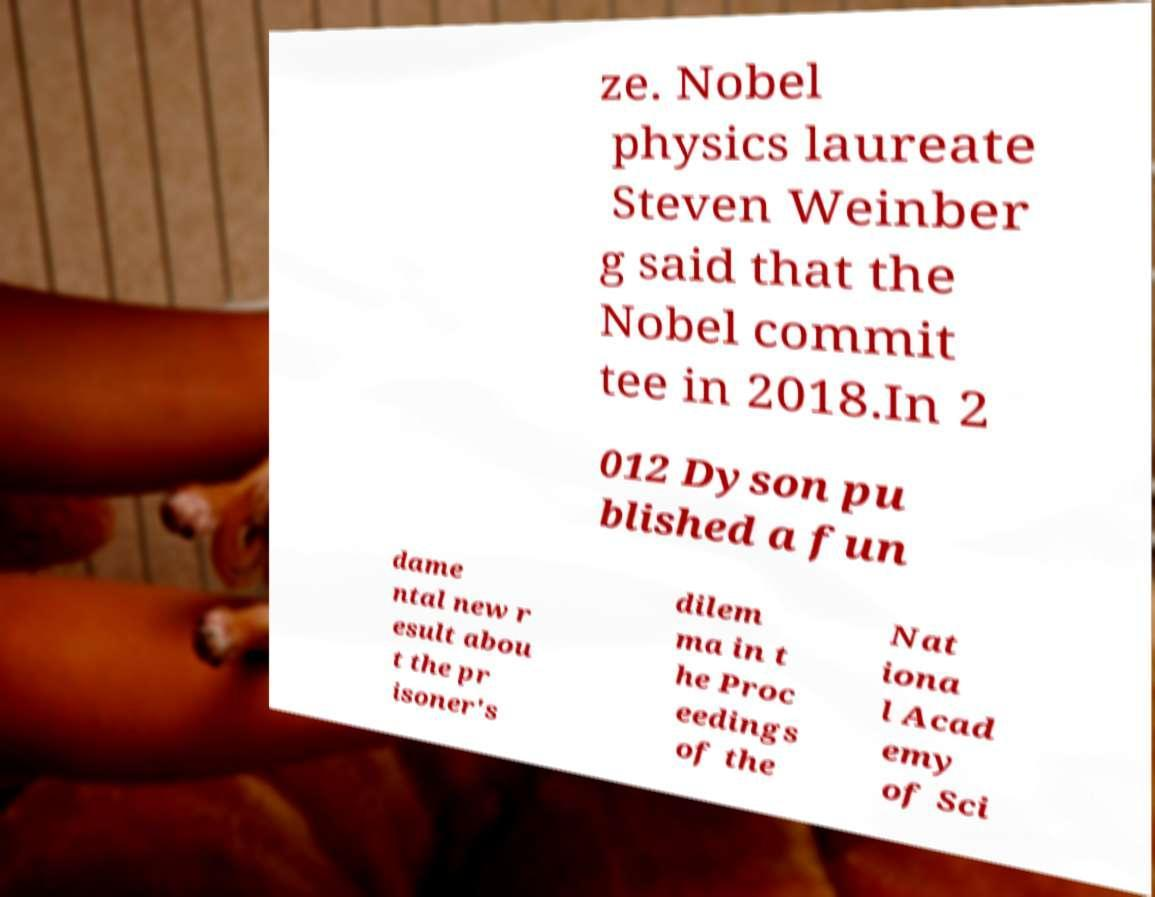Could you extract and type out the text from this image? ze. Nobel physics laureate Steven Weinber g said that the Nobel commit tee in 2018.In 2 012 Dyson pu blished a fun dame ntal new r esult abou t the pr isoner's dilem ma in t he Proc eedings of the Nat iona l Acad emy of Sci 